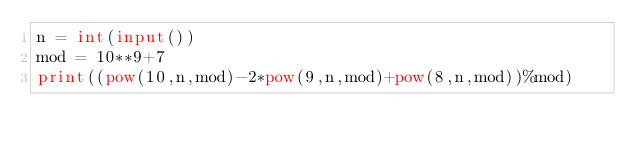<code> <loc_0><loc_0><loc_500><loc_500><_Python_>n = int(input())
mod = 10**9+7
print((pow(10,n,mod)-2*pow(9,n,mod)+pow(8,n,mod))%mod)</code> 